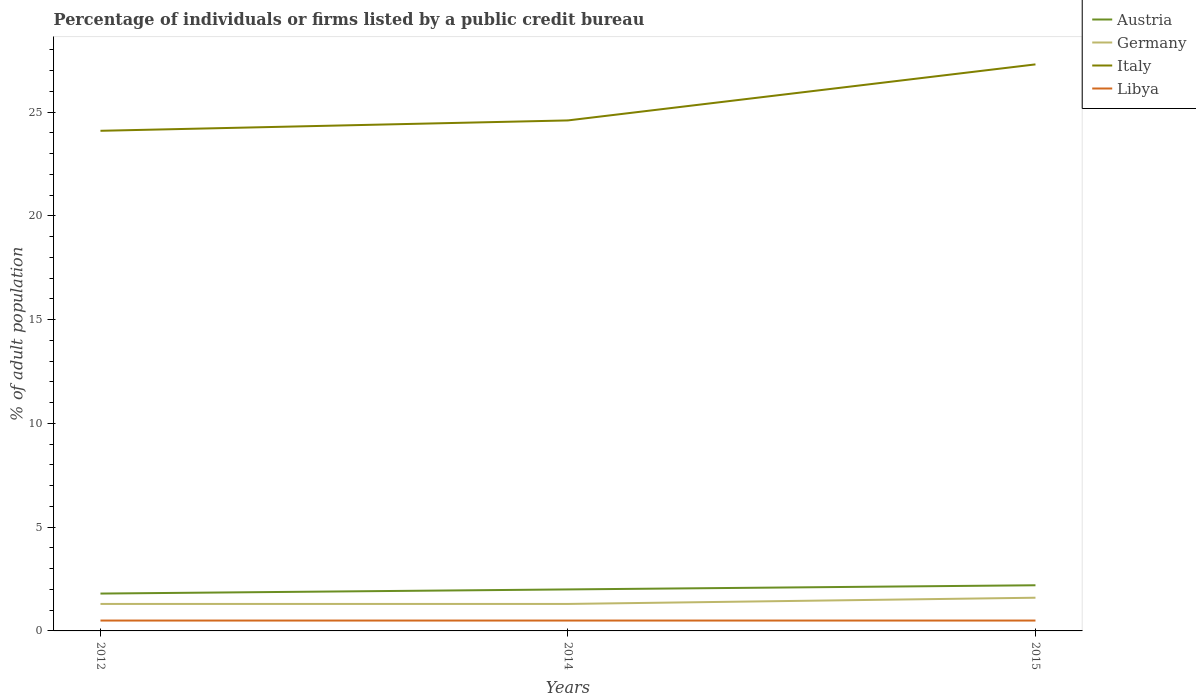Does the line corresponding to Austria intersect with the line corresponding to Italy?
Offer a terse response. No. In which year was the percentage of population listed by a public credit bureau in Germany maximum?
Keep it short and to the point. 2012. What is the total percentage of population listed by a public credit bureau in Italy in the graph?
Make the answer very short. -2.7. What is the difference between the highest and the second highest percentage of population listed by a public credit bureau in Germany?
Give a very brief answer. 0.3. Is the percentage of population listed by a public credit bureau in Italy strictly greater than the percentage of population listed by a public credit bureau in Libya over the years?
Keep it short and to the point. No. How many years are there in the graph?
Your answer should be very brief. 3. Does the graph contain any zero values?
Make the answer very short. No. Where does the legend appear in the graph?
Keep it short and to the point. Top right. What is the title of the graph?
Your response must be concise. Percentage of individuals or firms listed by a public credit bureau. What is the label or title of the X-axis?
Your response must be concise. Years. What is the label or title of the Y-axis?
Make the answer very short. % of adult population. What is the % of adult population in Italy in 2012?
Give a very brief answer. 24.1. What is the % of adult population of Libya in 2012?
Provide a succinct answer. 0.5. What is the % of adult population in Austria in 2014?
Make the answer very short. 2. What is the % of adult population of Germany in 2014?
Offer a very short reply. 1.3. What is the % of adult population of Italy in 2014?
Offer a very short reply. 24.6. What is the % of adult population in Austria in 2015?
Give a very brief answer. 2.2. What is the % of adult population in Germany in 2015?
Your answer should be very brief. 1.6. What is the % of adult population of Italy in 2015?
Your response must be concise. 27.3. What is the % of adult population in Libya in 2015?
Give a very brief answer. 0.5. Across all years, what is the maximum % of adult population in Austria?
Ensure brevity in your answer.  2.2. Across all years, what is the maximum % of adult population in Italy?
Provide a short and direct response. 27.3. Across all years, what is the minimum % of adult population in Austria?
Offer a very short reply. 1.8. Across all years, what is the minimum % of adult population in Germany?
Offer a very short reply. 1.3. Across all years, what is the minimum % of adult population in Italy?
Give a very brief answer. 24.1. What is the total % of adult population of Germany in the graph?
Keep it short and to the point. 4.2. What is the total % of adult population of Italy in the graph?
Ensure brevity in your answer.  76. What is the difference between the % of adult population in Italy in 2012 and that in 2014?
Keep it short and to the point. -0.5. What is the difference between the % of adult population in Libya in 2012 and that in 2014?
Provide a short and direct response. 0. What is the difference between the % of adult population in Austria in 2012 and that in 2015?
Provide a succinct answer. -0.4. What is the difference between the % of adult population of Libya in 2012 and that in 2015?
Your response must be concise. 0. What is the difference between the % of adult population of Italy in 2014 and that in 2015?
Offer a terse response. -2.7. What is the difference between the % of adult population in Austria in 2012 and the % of adult population in Germany in 2014?
Your response must be concise. 0.5. What is the difference between the % of adult population in Austria in 2012 and the % of adult population in Italy in 2014?
Make the answer very short. -22.8. What is the difference between the % of adult population in Austria in 2012 and the % of adult population in Libya in 2014?
Provide a succinct answer. 1.3. What is the difference between the % of adult population in Germany in 2012 and the % of adult population in Italy in 2014?
Make the answer very short. -23.3. What is the difference between the % of adult population in Italy in 2012 and the % of adult population in Libya in 2014?
Your answer should be compact. 23.6. What is the difference between the % of adult population in Austria in 2012 and the % of adult population in Germany in 2015?
Keep it short and to the point. 0.2. What is the difference between the % of adult population in Austria in 2012 and the % of adult population in Italy in 2015?
Your answer should be compact. -25.5. What is the difference between the % of adult population in Italy in 2012 and the % of adult population in Libya in 2015?
Your answer should be compact. 23.6. What is the difference between the % of adult population in Austria in 2014 and the % of adult population in Germany in 2015?
Ensure brevity in your answer.  0.4. What is the difference between the % of adult population in Austria in 2014 and the % of adult population in Italy in 2015?
Your answer should be very brief. -25.3. What is the difference between the % of adult population of Italy in 2014 and the % of adult population of Libya in 2015?
Your response must be concise. 24.1. What is the average % of adult population of Austria per year?
Make the answer very short. 2. What is the average % of adult population of Italy per year?
Offer a terse response. 25.33. What is the average % of adult population in Libya per year?
Make the answer very short. 0.5. In the year 2012, what is the difference between the % of adult population of Austria and % of adult population of Germany?
Your answer should be very brief. 0.5. In the year 2012, what is the difference between the % of adult population of Austria and % of adult population of Italy?
Offer a very short reply. -22.3. In the year 2012, what is the difference between the % of adult population in Austria and % of adult population in Libya?
Offer a very short reply. 1.3. In the year 2012, what is the difference between the % of adult population in Germany and % of adult population in Italy?
Offer a very short reply. -22.8. In the year 2012, what is the difference between the % of adult population of Germany and % of adult population of Libya?
Make the answer very short. 0.8. In the year 2012, what is the difference between the % of adult population of Italy and % of adult population of Libya?
Give a very brief answer. 23.6. In the year 2014, what is the difference between the % of adult population in Austria and % of adult population in Germany?
Make the answer very short. 0.7. In the year 2014, what is the difference between the % of adult population in Austria and % of adult population in Italy?
Your answer should be very brief. -22.6. In the year 2014, what is the difference between the % of adult population of Germany and % of adult population of Italy?
Keep it short and to the point. -23.3. In the year 2014, what is the difference between the % of adult population in Italy and % of adult population in Libya?
Make the answer very short. 24.1. In the year 2015, what is the difference between the % of adult population in Austria and % of adult population in Germany?
Your answer should be very brief. 0.6. In the year 2015, what is the difference between the % of adult population in Austria and % of adult population in Italy?
Your response must be concise. -25.1. In the year 2015, what is the difference between the % of adult population in Austria and % of adult population in Libya?
Provide a short and direct response. 1.7. In the year 2015, what is the difference between the % of adult population in Germany and % of adult population in Italy?
Offer a very short reply. -25.7. In the year 2015, what is the difference between the % of adult population in Germany and % of adult population in Libya?
Provide a short and direct response. 1.1. In the year 2015, what is the difference between the % of adult population of Italy and % of adult population of Libya?
Provide a succinct answer. 26.8. What is the ratio of the % of adult population of Italy in 2012 to that in 2014?
Provide a succinct answer. 0.98. What is the ratio of the % of adult population of Austria in 2012 to that in 2015?
Ensure brevity in your answer.  0.82. What is the ratio of the % of adult population of Germany in 2012 to that in 2015?
Provide a short and direct response. 0.81. What is the ratio of the % of adult population in Italy in 2012 to that in 2015?
Provide a short and direct response. 0.88. What is the ratio of the % of adult population in Germany in 2014 to that in 2015?
Your answer should be compact. 0.81. What is the ratio of the % of adult population of Italy in 2014 to that in 2015?
Make the answer very short. 0.9. What is the ratio of the % of adult population in Libya in 2014 to that in 2015?
Offer a very short reply. 1. What is the difference between the highest and the second highest % of adult population of Italy?
Keep it short and to the point. 2.7. What is the difference between the highest and the second highest % of adult population in Libya?
Provide a short and direct response. 0. What is the difference between the highest and the lowest % of adult population of Austria?
Make the answer very short. 0.4. What is the difference between the highest and the lowest % of adult population of Germany?
Your answer should be very brief. 0.3. What is the difference between the highest and the lowest % of adult population of Italy?
Give a very brief answer. 3.2. What is the difference between the highest and the lowest % of adult population of Libya?
Offer a terse response. 0. 